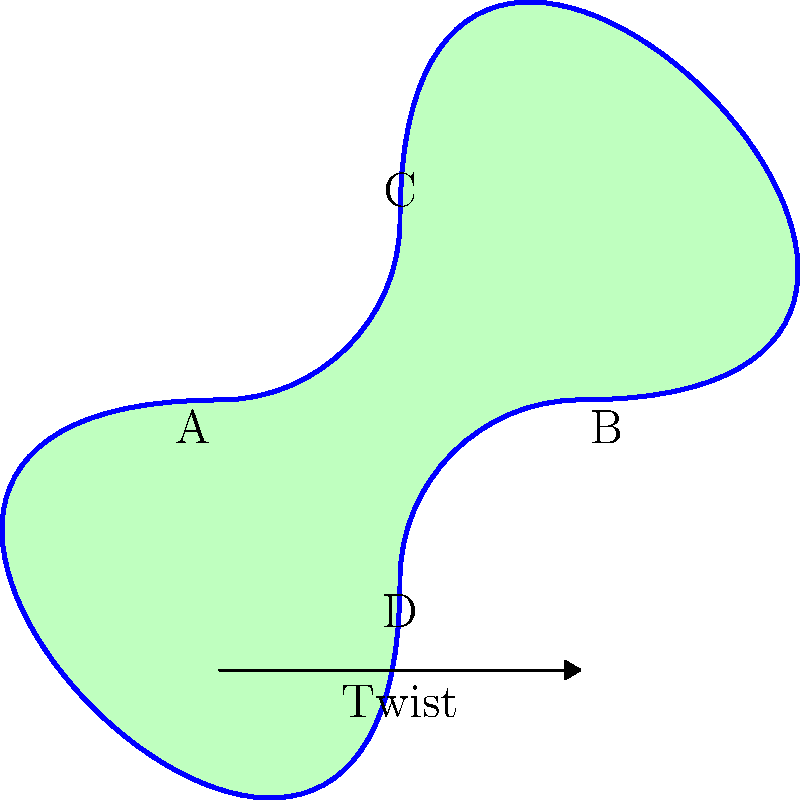In the context of creating a painted Möbius strip artwork, how many times would you need to twist a rectangular canvas before joining its ends to create a true Möbius strip? Consider the impact on the continuity of your painted design. To understand the creation of a Möbius strip in the context of painting, let's follow these steps:

1. Start with a rectangular canvas, representing a strip with two distinct sides (front and back).

2. The key property of a Möbius strip is that it has only one side and one edge. To achieve this:
   a) Take one end of the rectangle.
   b) Rotate it 180 degrees (half a turn).
   c) Connect it to the other end.

3. This single half-twist is crucial because:
   - It creates the continuous, one-sided surface characteristic of a Möbius strip.
   - If you were to paint along the surface, your brush would cover the entire strip without lifting.

4. The number of twists affects the topology:
   - An even number of half-twists (1 full twist, 2 full twists, etc.) results in a two-sided surface.
   - Only an odd number of half-twists creates a one-sided surface.

5. For a true Möbius strip, the minimum and most common number of half-twists is one.

6. In terms of your painting:
   - With one half-twist, a continuous design would seamlessly wrap around the entire surface.
   - This allows for interesting artistic effects where the design flows uninterrupted along the strip.

Therefore, to create a true Möbius strip for your artwork, you need to apply exactly one half-twist (180 degrees) before joining the ends of your canvas.
Answer: One half-twist (180 degrees) 